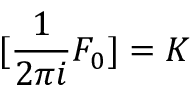<formula> <loc_0><loc_0><loc_500><loc_500>[ { \frac { 1 } { 2 \pi i } } F _ { 0 } ] = K</formula> 